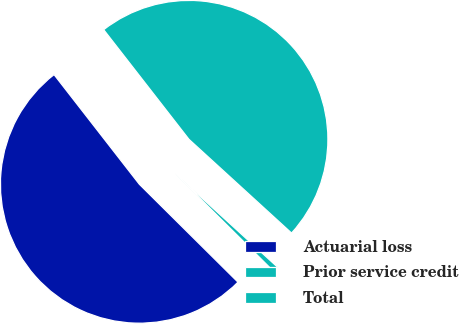Convert chart to OTSL. <chart><loc_0><loc_0><loc_500><loc_500><pie_chart><fcel>Actuarial loss<fcel>Prior service credit<fcel>Total<nl><fcel>52.03%<fcel>0.66%<fcel>47.3%<nl></chart> 